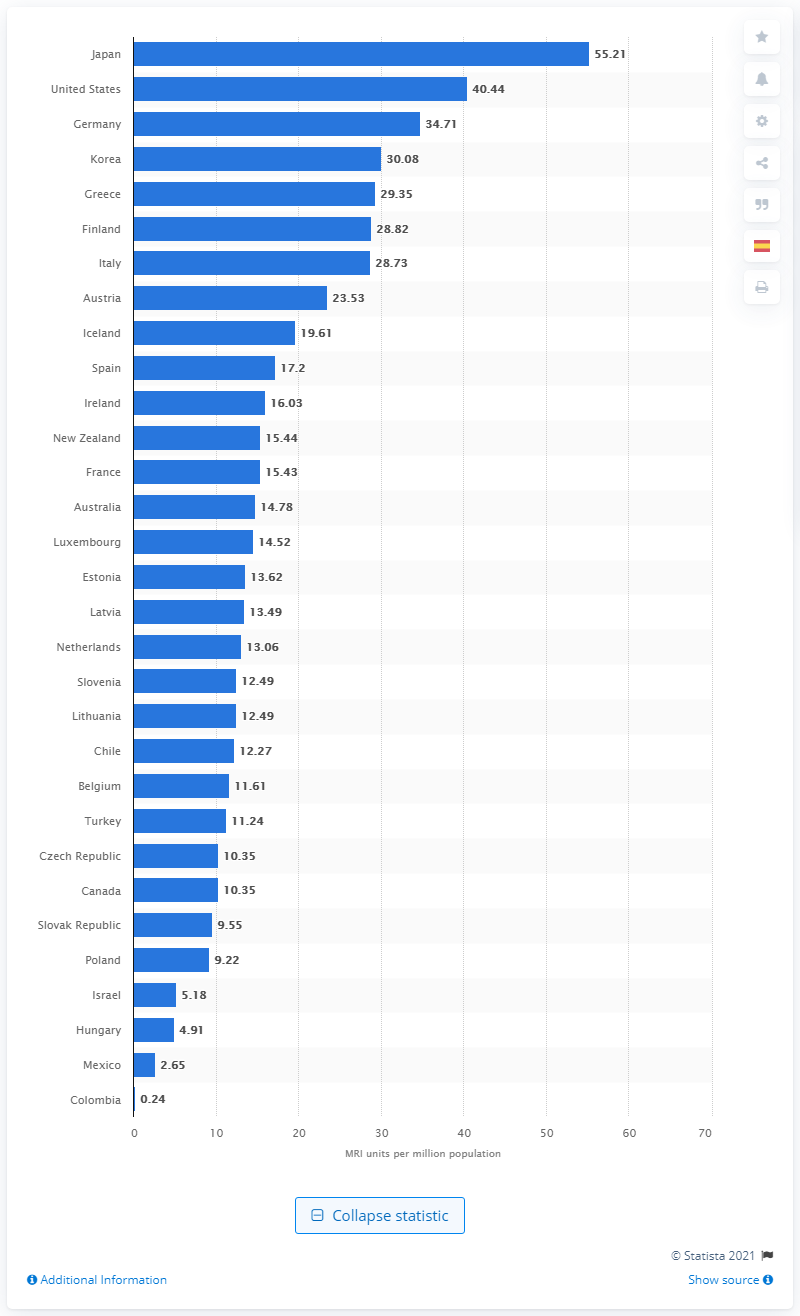Indicate a few pertinent items in this graphic. Japan has the highest density of MRI units, making it a leader in medical imaging technology. 